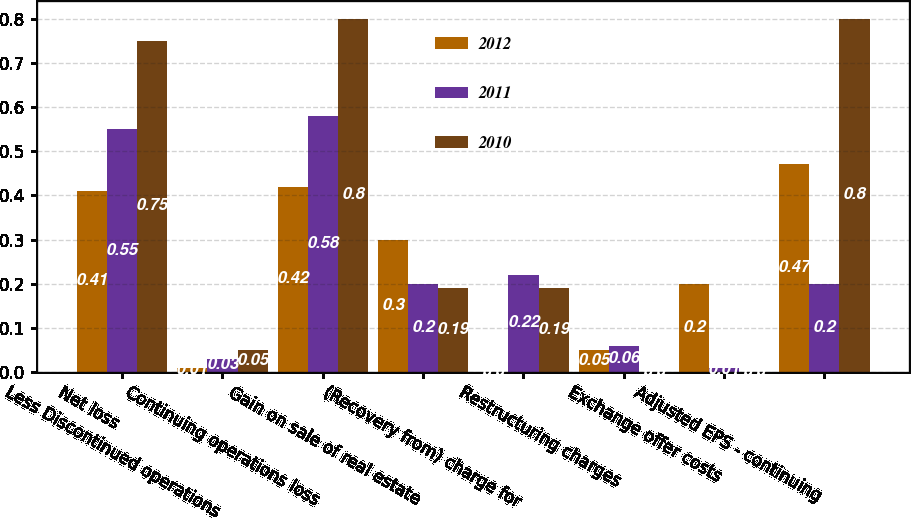<chart> <loc_0><loc_0><loc_500><loc_500><stacked_bar_chart><ecel><fcel>Net loss<fcel>Less Discontinued operations<fcel>Continuing operations loss<fcel>Gain on sale of real estate<fcel>(Recovery from) charge for<fcel>Restructuring charges<fcel>Exchange offer costs<fcel>Adjusted EPS - continuing<nl><fcel>2012<fcel>0.41<fcel>0.01<fcel>0.42<fcel>0.3<fcel>0<fcel>0.05<fcel>0.2<fcel>0.47<nl><fcel>2011<fcel>0.55<fcel>0.03<fcel>0.58<fcel>0.2<fcel>0.22<fcel>0.06<fcel>0.01<fcel>0.2<nl><fcel>2010<fcel>0.75<fcel>0.05<fcel>0.8<fcel>0.19<fcel>0.19<fcel>0<fcel>0<fcel>0.8<nl></chart> 